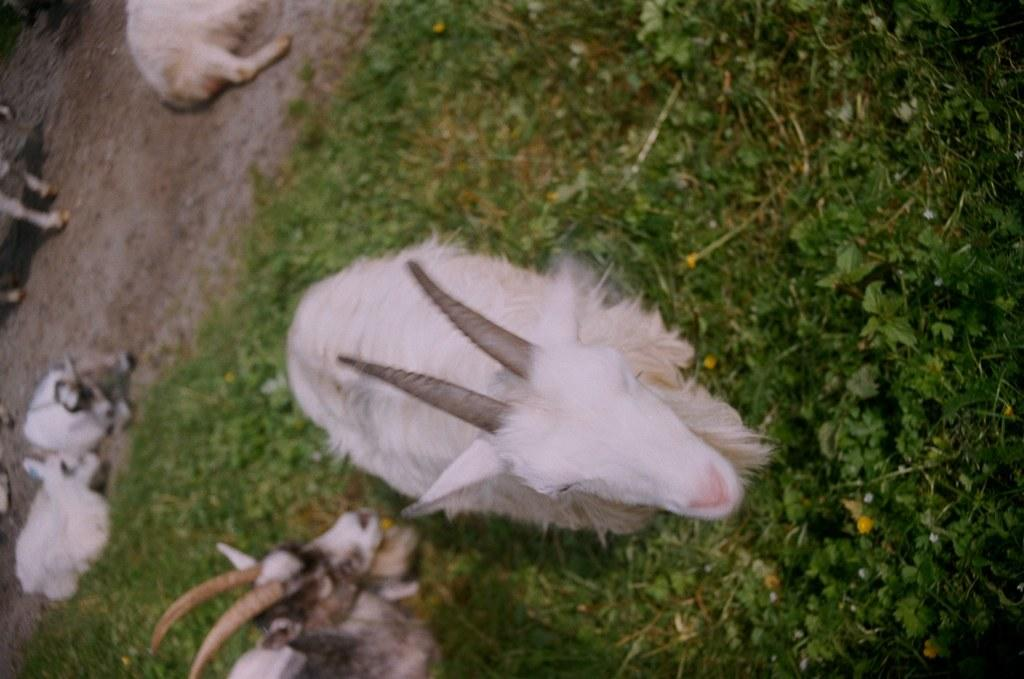What types of living organisms can be seen in the image? There are animals in the image. What type of vegetation is on the right side of the image? There is grass on the right side of the image. What kind of pathway is on the left side of the image? There is a walkway on the left side of the image. What type of corn can be seen growing on the frame in the image? There is no corn or frame present in the image; it features animals and a walkway. 